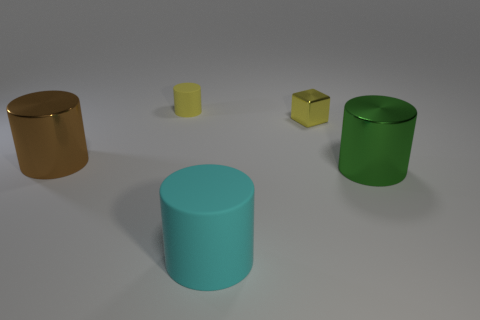Add 1 small things. How many objects exist? 6 Subtract all cubes. How many objects are left? 4 Add 3 big cylinders. How many big cylinders are left? 6 Add 3 large blue cubes. How many large blue cubes exist? 3 Subtract 0 red cubes. How many objects are left? 5 Subtract all cyan objects. Subtract all big green objects. How many objects are left? 3 